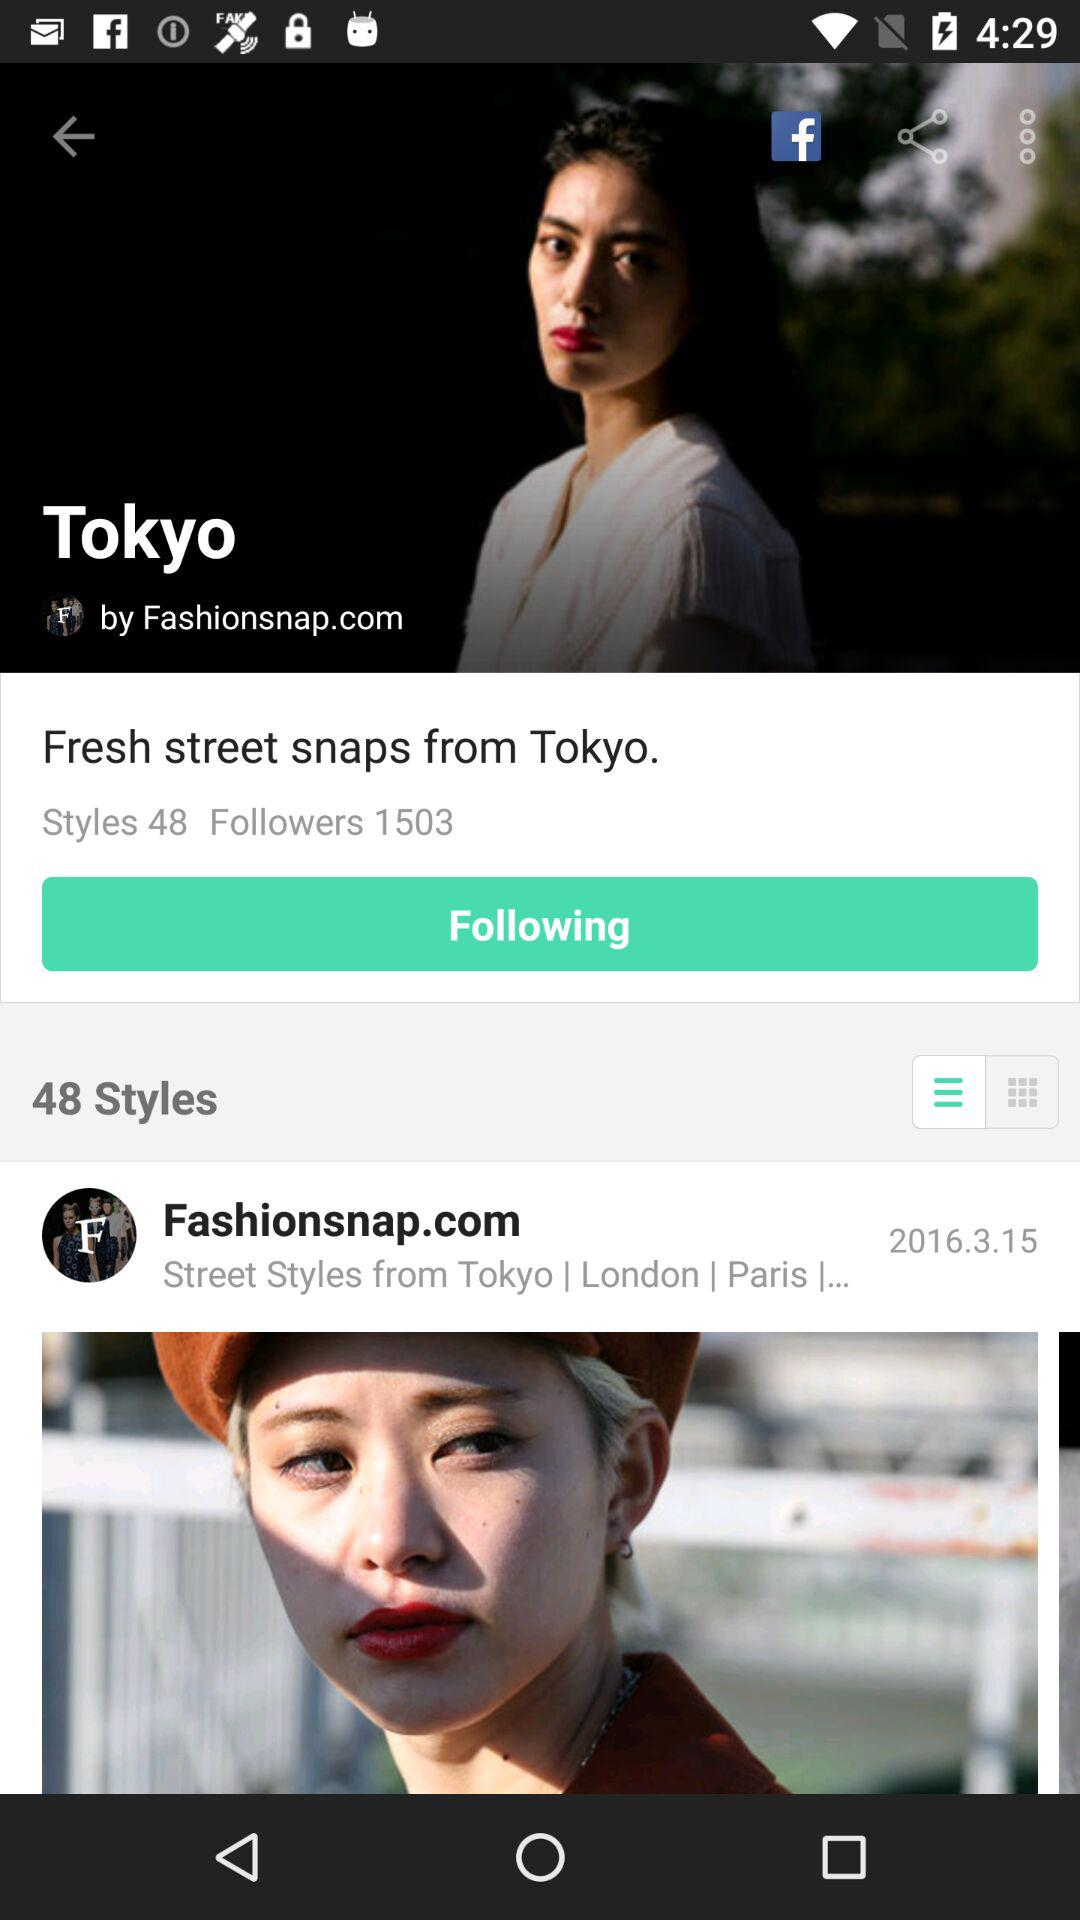How many followers are there? There are 1503 followers. 